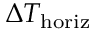<formula> <loc_0><loc_0><loc_500><loc_500>\Delta T _ { h o r i z }</formula> 